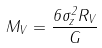Convert formula to latex. <formula><loc_0><loc_0><loc_500><loc_500>M _ { V } = \frac { 6 \sigma _ { z } ^ { 2 } R _ { V } } { G }</formula> 